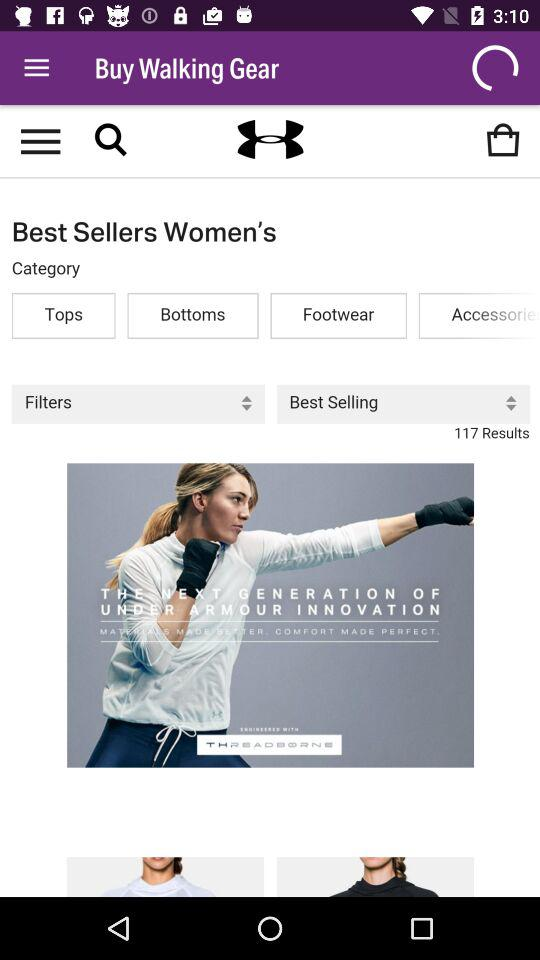What is the total number of results shown in the selected category? The total number of results shown is 117. 